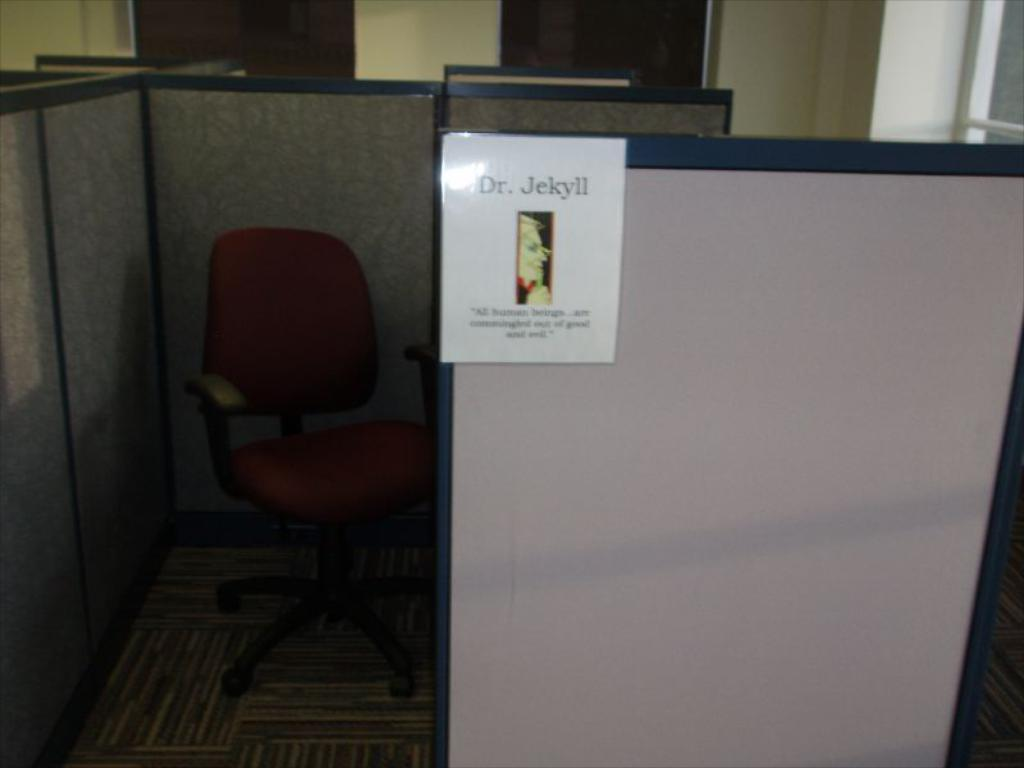<image>
Offer a succinct explanation of the picture presented. The person who sits at this desk is nicknamed Dr Jekyll. 